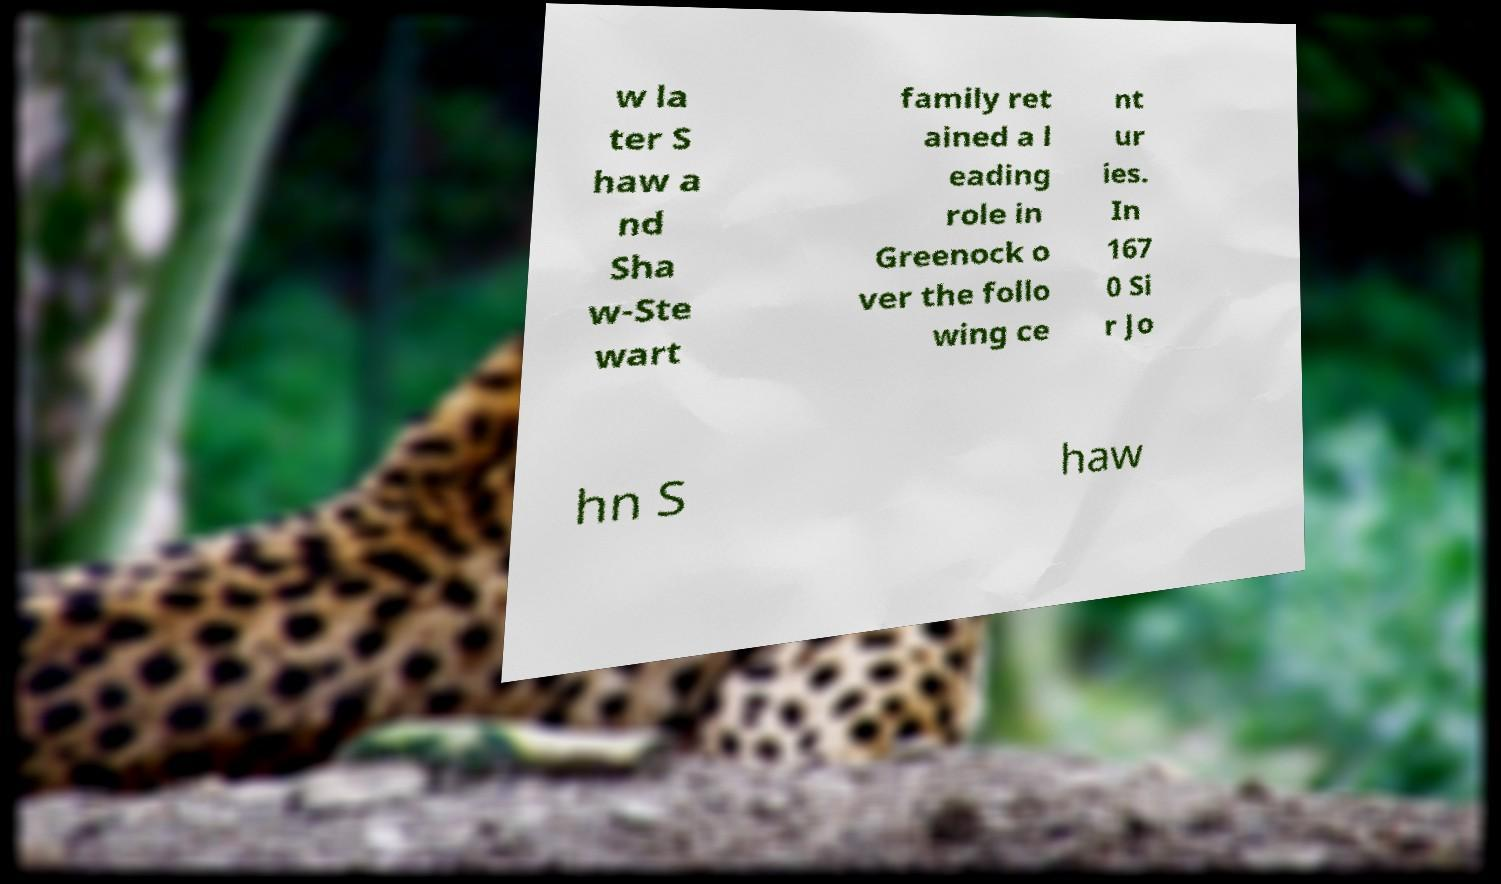Can you read and provide the text displayed in the image?This photo seems to have some interesting text. Can you extract and type it out for me? w la ter S haw a nd Sha w-Ste wart family ret ained a l eading role in Greenock o ver the follo wing ce nt ur ies. In 167 0 Si r Jo hn S haw 